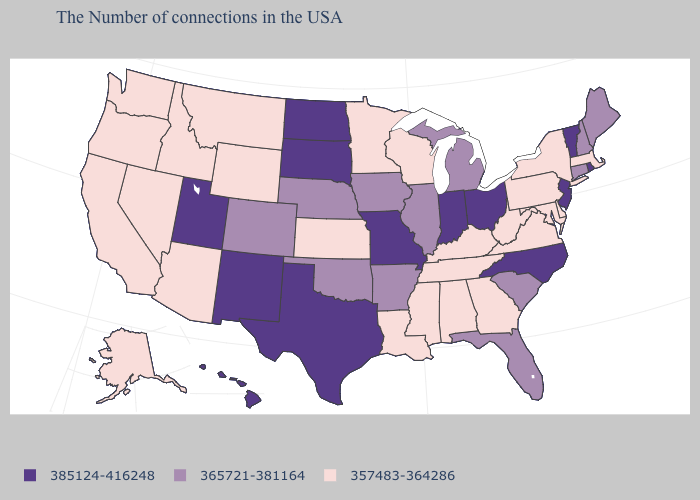Among the states that border Nevada , does Utah have the lowest value?
Quick response, please. No. What is the highest value in the West ?
Quick response, please. 385124-416248. Is the legend a continuous bar?
Concise answer only. No. Does the map have missing data?
Give a very brief answer. No. What is the value of Nevada?
Concise answer only. 357483-364286. Among the states that border Alabama , does Mississippi have the lowest value?
Short answer required. Yes. What is the value of Montana?
Write a very short answer. 357483-364286. Does Vermont have the same value as New Jersey?
Write a very short answer. Yes. What is the value of Iowa?
Answer briefly. 365721-381164. Among the states that border South Dakota , which have the lowest value?
Concise answer only. Minnesota, Wyoming, Montana. What is the highest value in the West ?
Write a very short answer. 385124-416248. What is the lowest value in the MidWest?
Concise answer only. 357483-364286. Does Mississippi have the same value as Oregon?
Give a very brief answer. Yes. What is the highest value in the Northeast ?
Answer briefly. 385124-416248. Among the states that border Pennsylvania , does Delaware have the highest value?
Short answer required. No. 